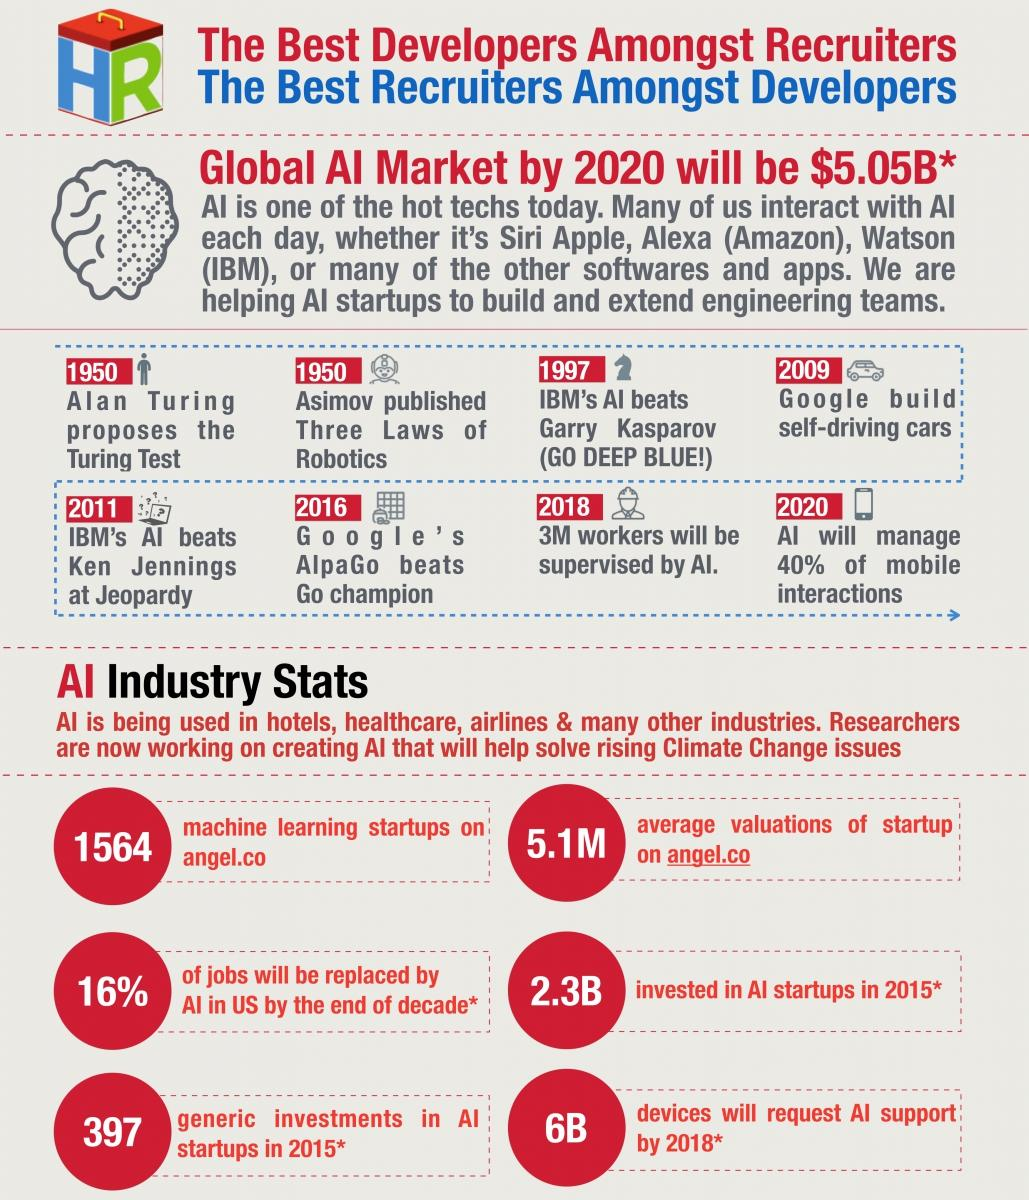Draw attention to some important aspects in this diagram. Asimov published a series of works that included the three laws of robotics. Ken Jennings was defeated by an artificial intelligence in 2011. By 2018, 3M workers will be supervised by AI. Daily interactions with AI often involve the use of popular voice assistants such as Siri by Apple, Alexa (Amazon), and Watson (IBM). The three laws of robotics were published in 1950. 